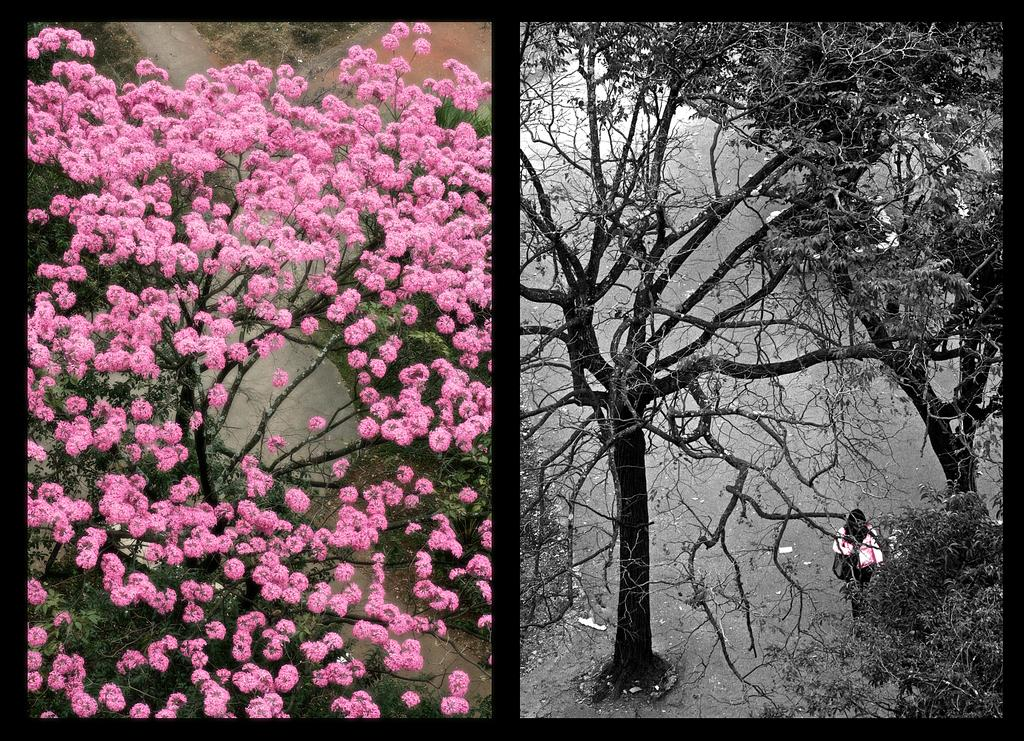Who is the main subject in the image? There is a woman in the image. What is the woman doing in the image? The woman is walking on the road. Where is the woman located in relation to the trees? The woman is under the trees. What can be seen on the left side of the image? There are flowers on the left side of the image. Can you see any islands or the sea in the image? No, there are no islands or sea visible in the image. Is there a rainstorm happening in the image? No, there is no indication of a rainstorm in the image. 